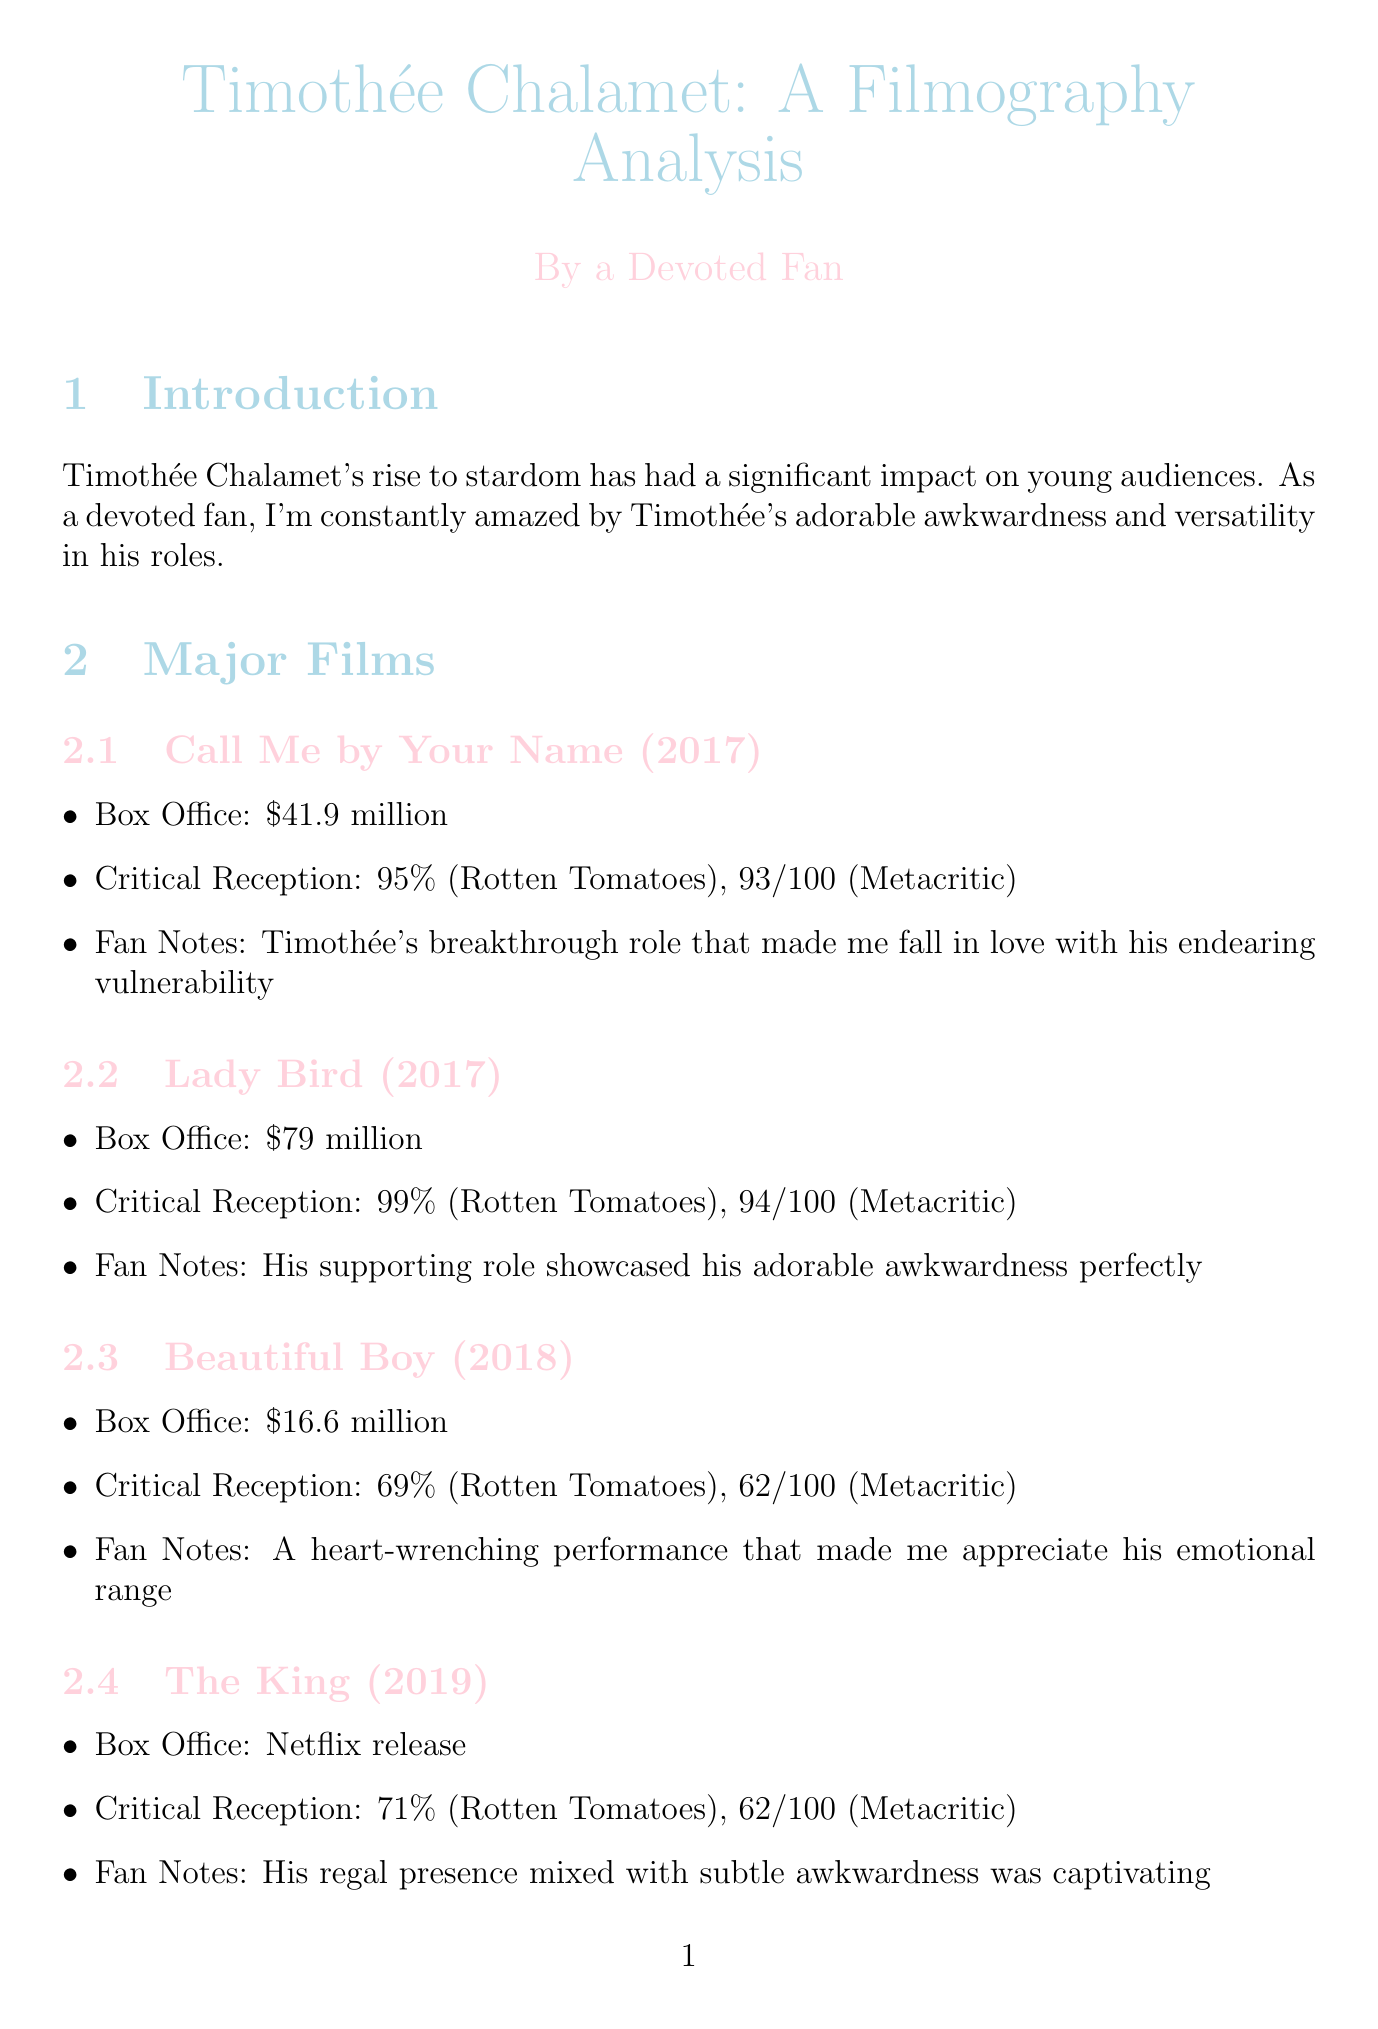What is Timothée Chalamet's highest-grossing film? The document indicates that "Dune" is Timothée's highest-grossing film with a box office of $401.8 million.
Answer: Dune What year was "Call Me by Your Name" released? The document specifies that "Call Me by Your Name" was released in 2017.
Answer: 2017 What was the box office for "Little Women"? The document states that "Little Women" had a box office of $218.9 million.
Answer: $218.9 million What critical reception did "Lady Bird" receive on Rotten Tomatoes? According to the document, "Lady Bird" received a 99% rating on Rotten Tomatoes.
Answer: 99% Which film demonstrated Timothée's genre versatility? The document mentions that his filmography showcases a demonstrated ability to excel in various genres, implying all films, but highlights "Dune" for representing versatility in sci-fi.
Answer: Dune What notable award nomination did Timothée receive? The document notes that he received an Oscar nomination for "Call Me by Your Name."
Answer: Oscar nomination In which year is "Wonka" anticipated to release? The document indicates that "Wonka" is anticipated to release in 2023.
Answer: 2023 How many films are listed in the major films section? The document lists a total of six major films.
Answer: Six What is Timothée's social media impact described as? The document describes Timothée's social media presence as having a massive following that adores his quirky posts.
Answer: Massive following 